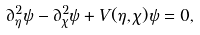Convert formula to latex. <formula><loc_0><loc_0><loc_500><loc_500>\partial ^ { 2 } _ { \eta } \psi - \partial ^ { 2 } _ { \chi } \psi + V ( \eta , \chi ) \psi = 0 ,</formula> 